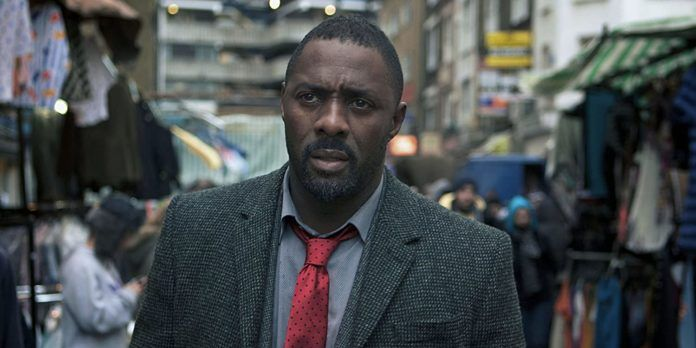What kind of emotions does the character in the image evoke and why? The character in the image evokes a profound sense of determination and resolve. His intense gaze and serious expression suggest he is deeply focused on unraveling a complex situation. There is a hint of weariness, implying that he has faced many challenges, but his posture and presence indicate unwavering commitment to his cause. The juxtaposition of his formal attire in the casual market setting adds a layer of intrigue and complexity, hinting at the gravity of his role in maintaining order amidst chaos. Describe an ordinary day at this market without focusing on the main character. On an ordinary day, the market is abuzz with activity from dawn till dusk. Vendors shout out their wares, from fresh produce to colorful fabrics, enticing passersby with the best deals. Shoppers haggle over prices, examining goods with critical eyes. The air is thick with the aromas of street food—sizzling meats, fresh-baked bread, and spices. Children weave through the crowd, their laughter mingling with the din. Street musicians play lively tunes, adding a rhythmic backdrop to the hustle and bustle. Occasional calls from market security remind everyone to be vigilant, creating a steady hum of organized chaos where each day brings new faces and stories. 